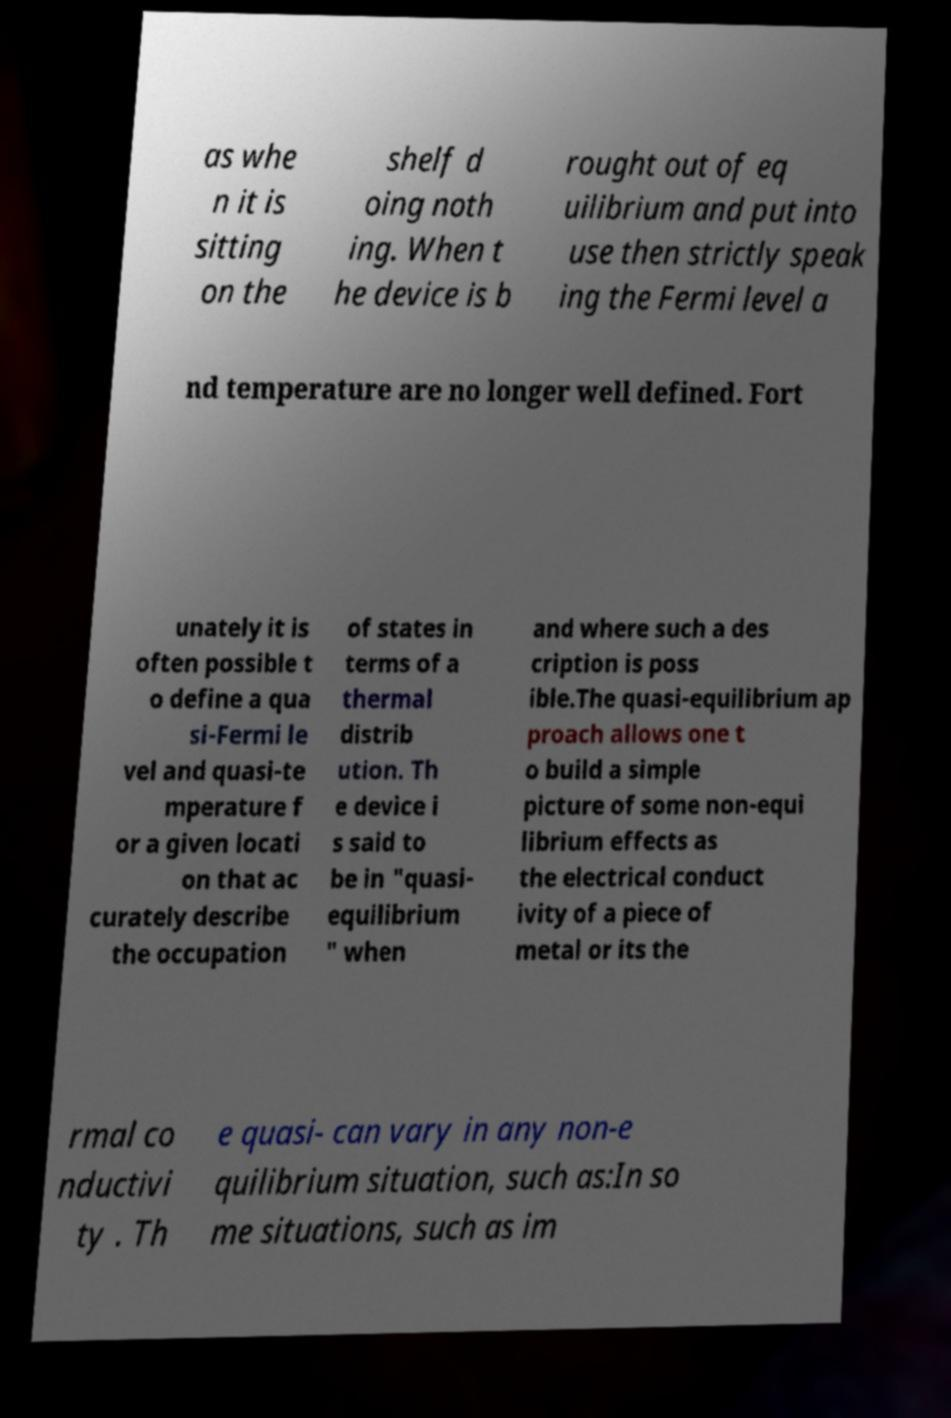Please identify and transcribe the text found in this image. as whe n it is sitting on the shelf d oing noth ing. When t he device is b rought out of eq uilibrium and put into use then strictly speak ing the Fermi level a nd temperature are no longer well defined. Fort unately it is often possible t o define a qua si-Fermi le vel and quasi-te mperature f or a given locati on that ac curately describe the occupation of states in terms of a thermal distrib ution. Th e device i s said to be in "quasi- equilibrium " when and where such a des cription is poss ible.The quasi-equilibrium ap proach allows one t o build a simple picture of some non-equi librium effects as the electrical conduct ivity of a piece of metal or its the rmal co nductivi ty . Th e quasi- can vary in any non-e quilibrium situation, such as:In so me situations, such as im 